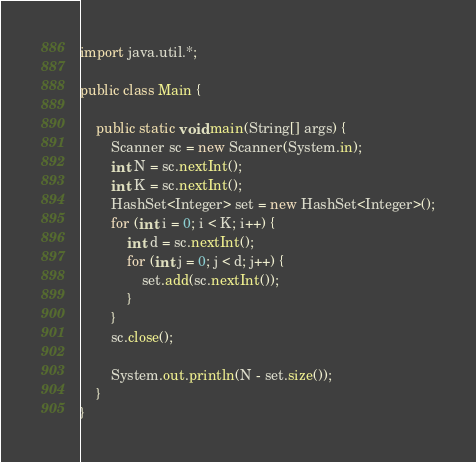Convert code to text. <code><loc_0><loc_0><loc_500><loc_500><_Java_>import java.util.*;

public class Main {

	public static void main(String[] args) {
		Scanner sc = new Scanner(System.in);
		int N = sc.nextInt();
		int K = sc.nextInt();
		HashSet<Integer> set = new HashSet<Integer>();
		for (int i = 0; i < K; i++) {
			int d = sc.nextInt();
			for (int j = 0; j < d; j++) {
				set.add(sc.nextInt());
			}
		}
		sc.close();

		System.out.println(N - set.size());
	}
}
</code> 